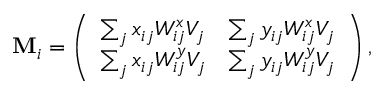Convert formula to latex. <formula><loc_0><loc_0><loc_500><loc_500>M _ { i } = \left ( \begin{array} { l l } { \sum _ { j } x _ { i j } W _ { i j } ^ { x } V _ { j } } & { \sum _ { j } y _ { i j } W _ { i j } ^ { x } V _ { j } } \\ { \sum _ { j } x _ { i j } W _ { i j } ^ { y } V _ { j } } & { \sum _ { j } y _ { i j } W _ { i j } ^ { y } V _ { j } } \end{array} \right ) ,</formula> 